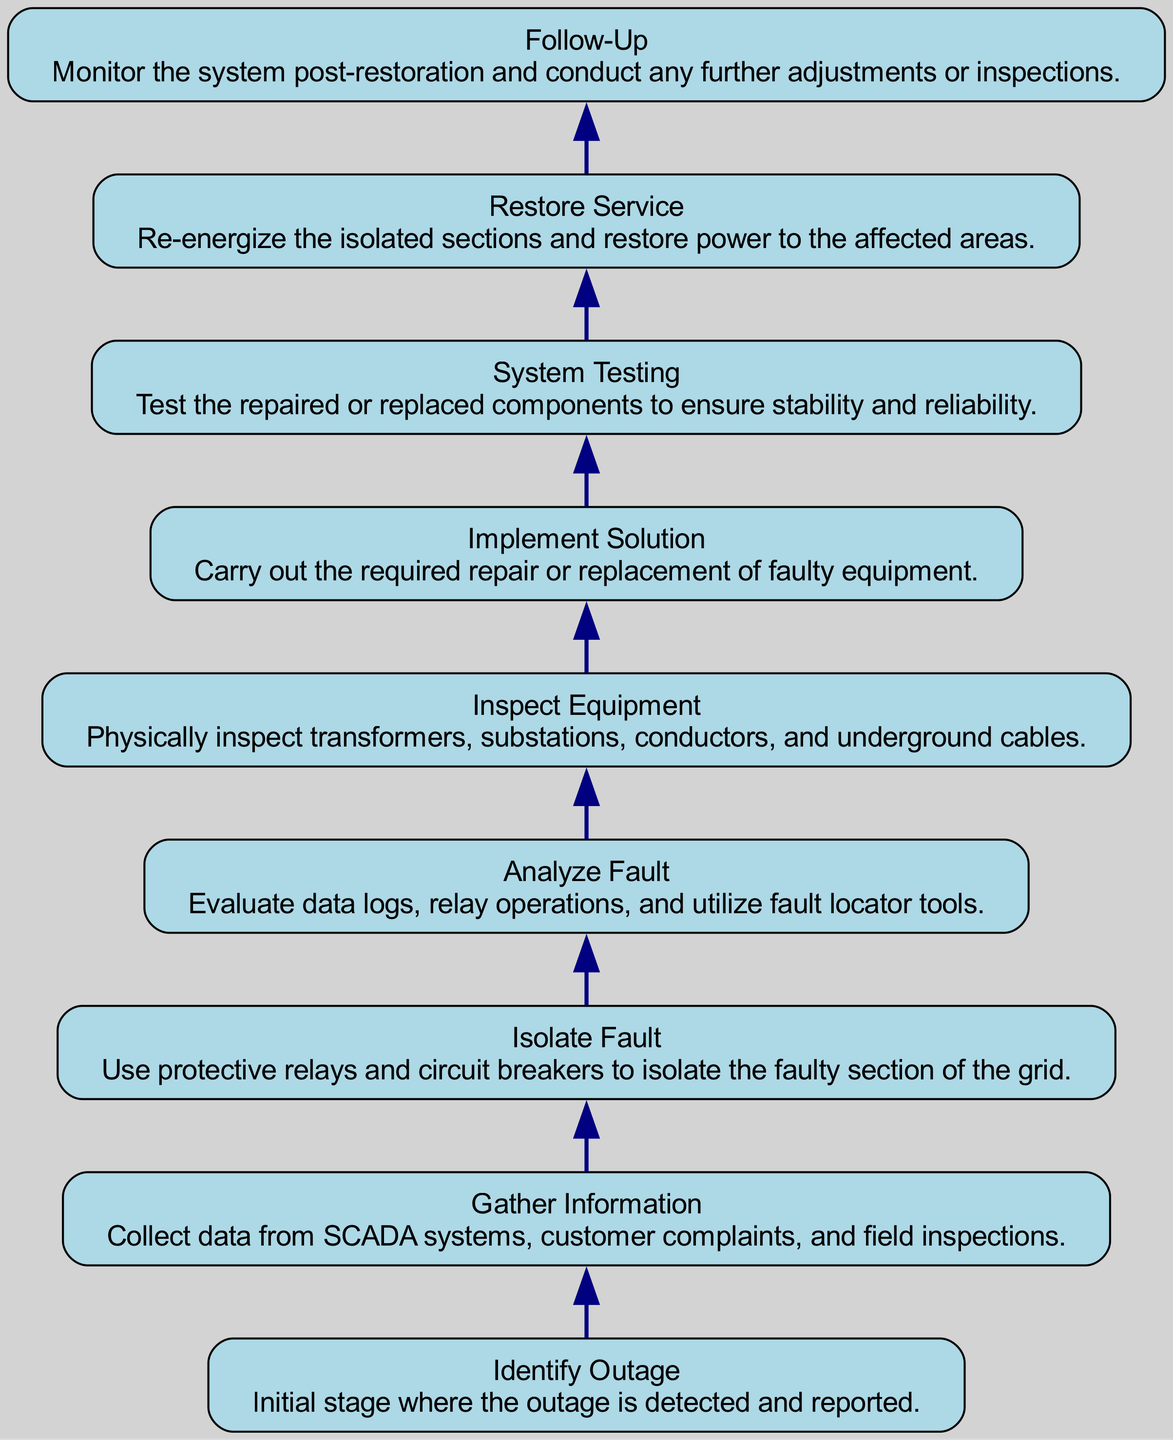What is the first step in the troubleshooting process? The diagram starts with "Identify Outage" as the first step, which outlines the initial detection and reporting of the outage.
Answer: Identify Outage How many nodes are there in the diagram? The diagram includes 9 distinct stages, each representing a step in the troubleshooting process, counting as nodes.
Answer: 9 What follows after "Inspect Equipment"? "Implement Solution" is the next step after "Inspect Equipment", detailing the actions taken based on the inspection outcomes.
Answer: Implement Solution Which step involves testing the repaired components? "System Testing" is the step dedicated to the testing of repaired or replaced components for stability and reliability.
Answer: System Testing What action is taken after restoring service? "Follow-Up" is the subsequent action that takes place after "Restore Service", involving monitoring and making any necessary adjustments.
Answer: Follow-Up Which two steps in the diagram directly relate to data analysis? "Gather Information" and "Analyze Fault" are the two steps that focus on collecting and evaluating data related to the outage.
Answer: Gather Information and Analyze Fault What edge connects "Isolate Fault" and "Analyze Fault"? The flow transition from "Isolate Fault" leads directly to "Analyze Fault", showing the progression in the troubleshooting process.
Answer: Analyze Fault How does "Restoring Service" depend on previous steps? "Restore Service" is contingent upon the completion of "System Testing", ensuring that all necessary evaluations are successfully executed before service restoration.
Answer: System Testing What is the last step in the diagram? "Follow-Up" is identified as the final step, which involves monitoring the system after service has been restored.
Answer: Follow-Up 